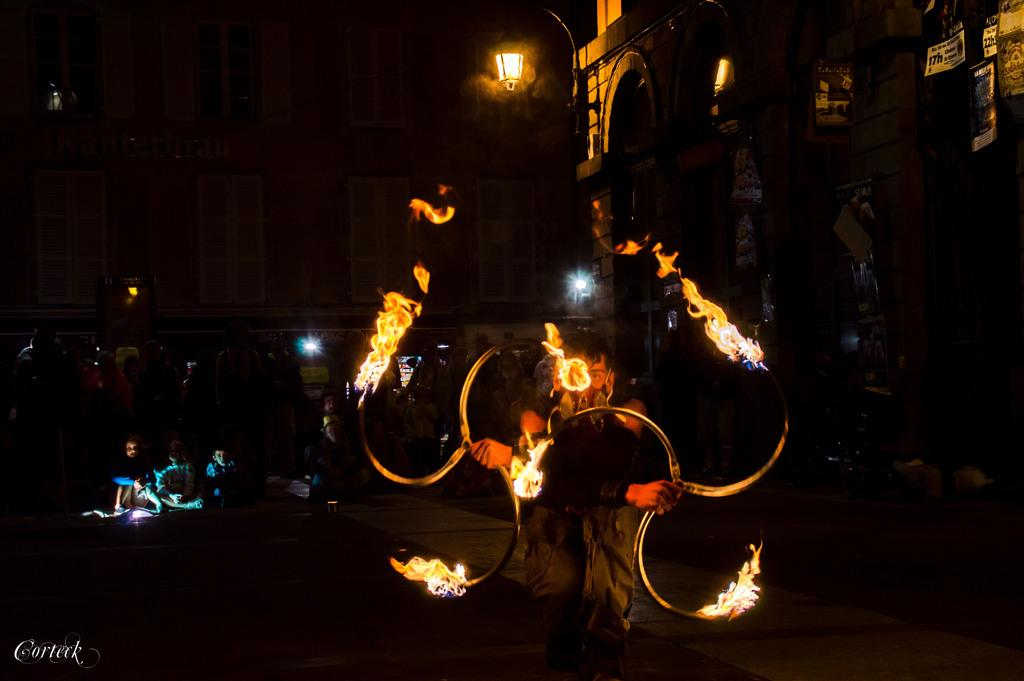What is the man in the image doing? The man is playing with fire in the image. Where are the people located in the image? The people are sitting on the left side of the image. What can be seen in the distance in the image? There are buildings in the background of the image. What is the source of light in the background of the image? There is light visible in the background of the image. What type of soup is being served in the circle in the image? There is no soup or circle present in the image. 